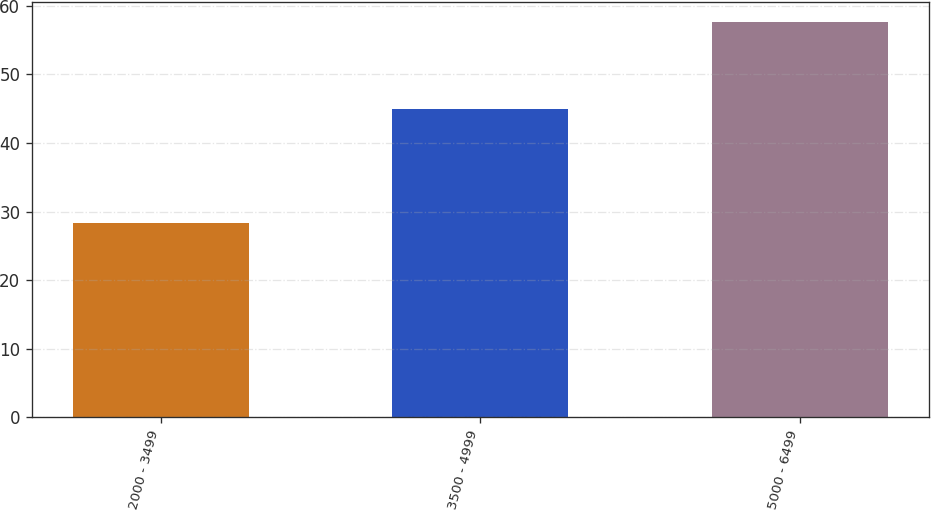Convert chart. <chart><loc_0><loc_0><loc_500><loc_500><bar_chart><fcel>2000 - 3499<fcel>3500 - 4999<fcel>5000 - 6499<nl><fcel>28.38<fcel>44.98<fcel>57.62<nl></chart> 